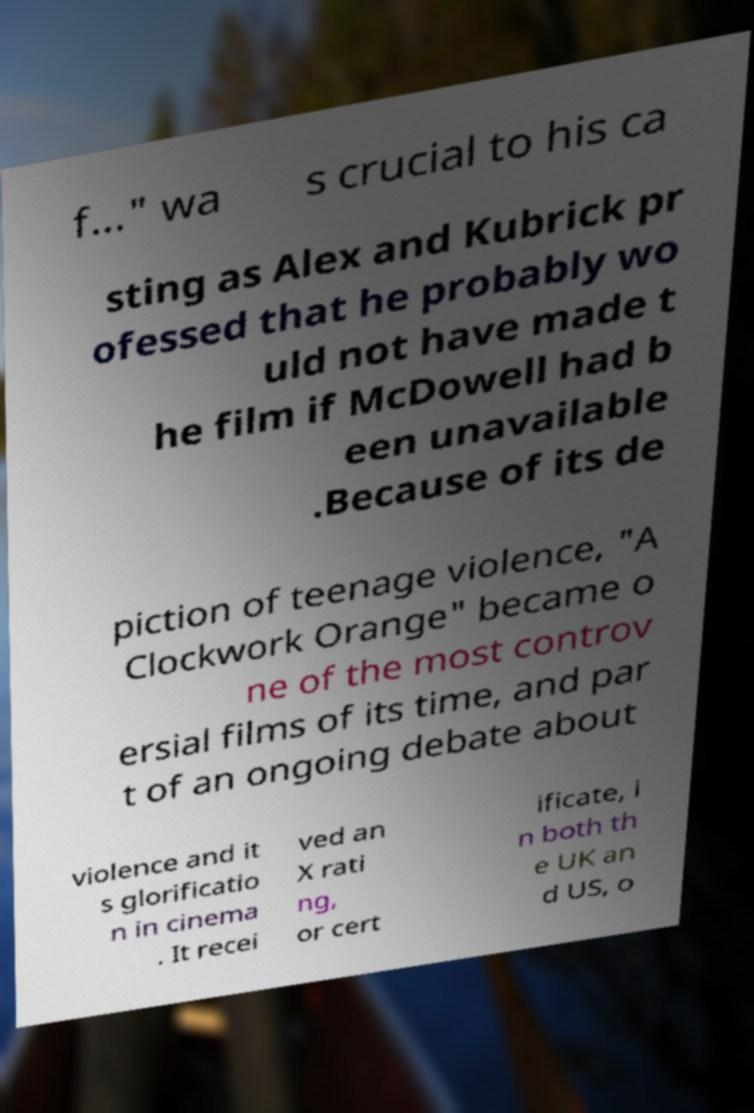Could you extract and type out the text from this image? f..." wa s crucial to his ca sting as Alex and Kubrick pr ofessed that he probably wo uld not have made t he film if McDowell had b een unavailable .Because of its de piction of teenage violence, "A Clockwork Orange" became o ne of the most controv ersial films of its time, and par t of an ongoing debate about violence and it s glorificatio n in cinema . It recei ved an X rati ng, or cert ificate, i n both th e UK an d US, o 